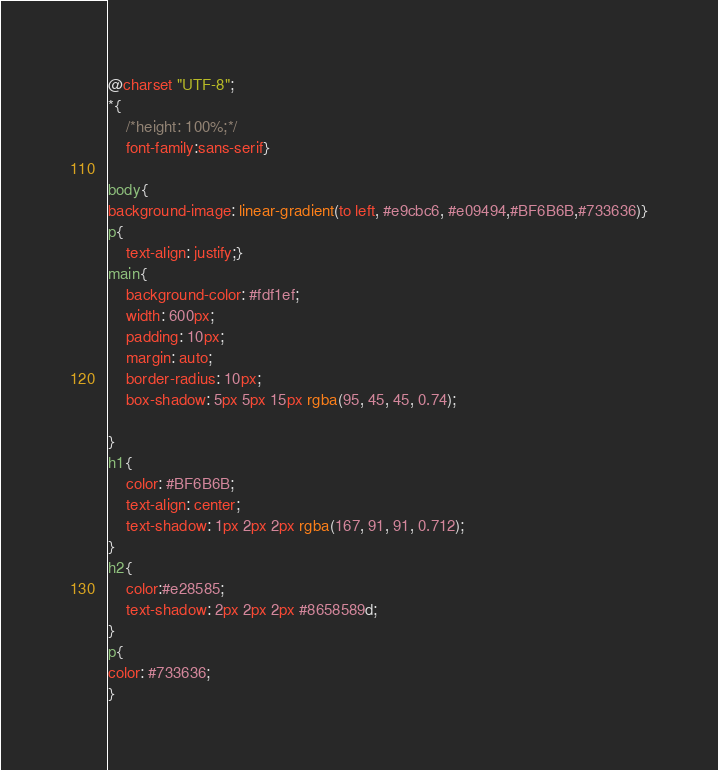Convert code to text. <code><loc_0><loc_0><loc_500><loc_500><_CSS_>@charset "UTF-8";
*{
    /*height: 100%;*/
    font-family:sans-serif}
    
body{
background-image: linear-gradient(to left, #e9cbc6, #e09494,#BF6B6B,#733636)}
p{
    text-align: justify;}
main{
    background-color: #fdf1ef;
    width: 600px;
    padding: 10px;
    margin: auto;
    border-radius: 10px;
    box-shadow: 5px 5px 15px rgba(95, 45, 45, 0.74);

}
h1{
    color: #BF6B6B;
    text-align: center;
    text-shadow: 1px 2px 2px rgba(167, 91, 91, 0.712);
}
h2{
    color:#e28585;
    text-shadow: 2px 2px 2px #8658589d;
}
p{
color: #733636;
}

</code> 